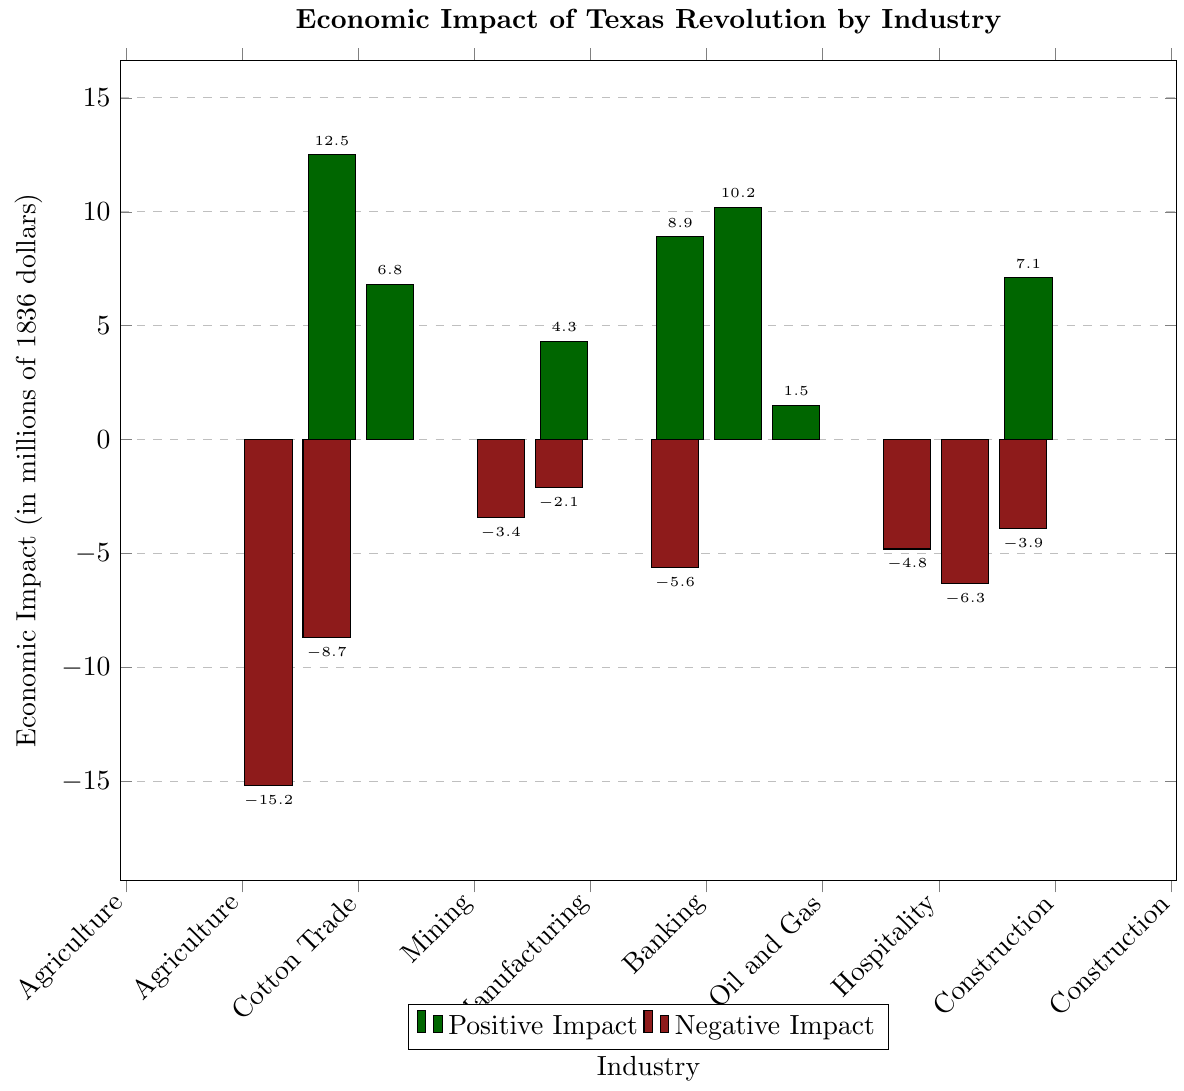Which industry experienced the highest negative economic impact due to the Texas Revolution? The bar representing Agriculture extends the lowest into the negative values in the chart, indicating it had the highest negative impact.
Answer: Agriculture Which industry had the second highest positive economic impact? The second tallest bar in the positive impact side belongs to Real Estate, after Cotton Trade which is the tallest.
Answer: Real Estate How much was the combined economic impact on Banking and Construction? Banking had an impact of 8.9 million dollars, and Construction had an impact of 7.1 million dollars. Adding these together gives 8.9 + 7.1 = 16 million dollars.
Answer: 16 million dollars Compare the economic impacts on Ranching and Real Estate. Which one was greater and by how much? Ranching had a negative impact of -8.7 million dollars, while Real Estate had a positive impact of 10.2 million dollars. The difference is 10.2 - (-8.7) = 10.2 + 8.7 = 18.9 million dollars.
Answer: Real Estate by 18.9 million dollars What is the average economic impact of the industries that experienced positive impacts? Add the positive impacts: Cotton Trade (12.5), Shipping (6.8), Manufacturing (4.3), Banking (8.9), Real Estate (10.2), Oil and Gas (1.5), and Construction (7.1), then divide by the 7 industries: (12.5 + 6.8 + 4.3 + 8.9 + 10.2 + 1.5 + 7.1) / 7 = 51.3 / 7 = 7.33 million dollars.
Answer: 7.33 million dollars Which industry had a similar economic impact to Hospitality? By observing the bars, both Hospitality and Transportation have similar lengths, with Hospitality at -6.3 million dollars and Transportation at -3.9 million dollars.
Answer: Transportation What is the total negative economic impact across all industries? Add the negative impacts: Agriculture (-15.2), Ranching (-8.7), Mining (-3.4), Timber (-2.1), Retail Trade (-5.6), Mercantile (-4.8), Hospitality (-6.3), and Transportation (-3.9): -15.2 - 8.7 - 3.4 - 2.1 - 5.6 - 4.8 - 6.3 - 3.9 = -49 million dollars.
Answer: -49 million dollars How does the impact on Manufacturing compare to Retail Trade? Manufacturing has a positive impact of 4.3 million dollars, whereas Retail Trade has a negative impact of -5.6 million dollars. Therefore, Manufacturing's impact is 4.3 + 5.6 = 9.9 million dollars greater than Retail Trade.
Answer: Manufacturing by 9.9 million dollars What is the range of economic impacts shown in the chart? The highest impact is Cotton Trade at 12.5 million dollars, and the lowest is Agriculture at -15.2 million dollars. The range is calculated as 12.5 - (-15.2) = 12.5 + 15.2 = 27.7 million dollars.
Answer: 27.7 million dollars 